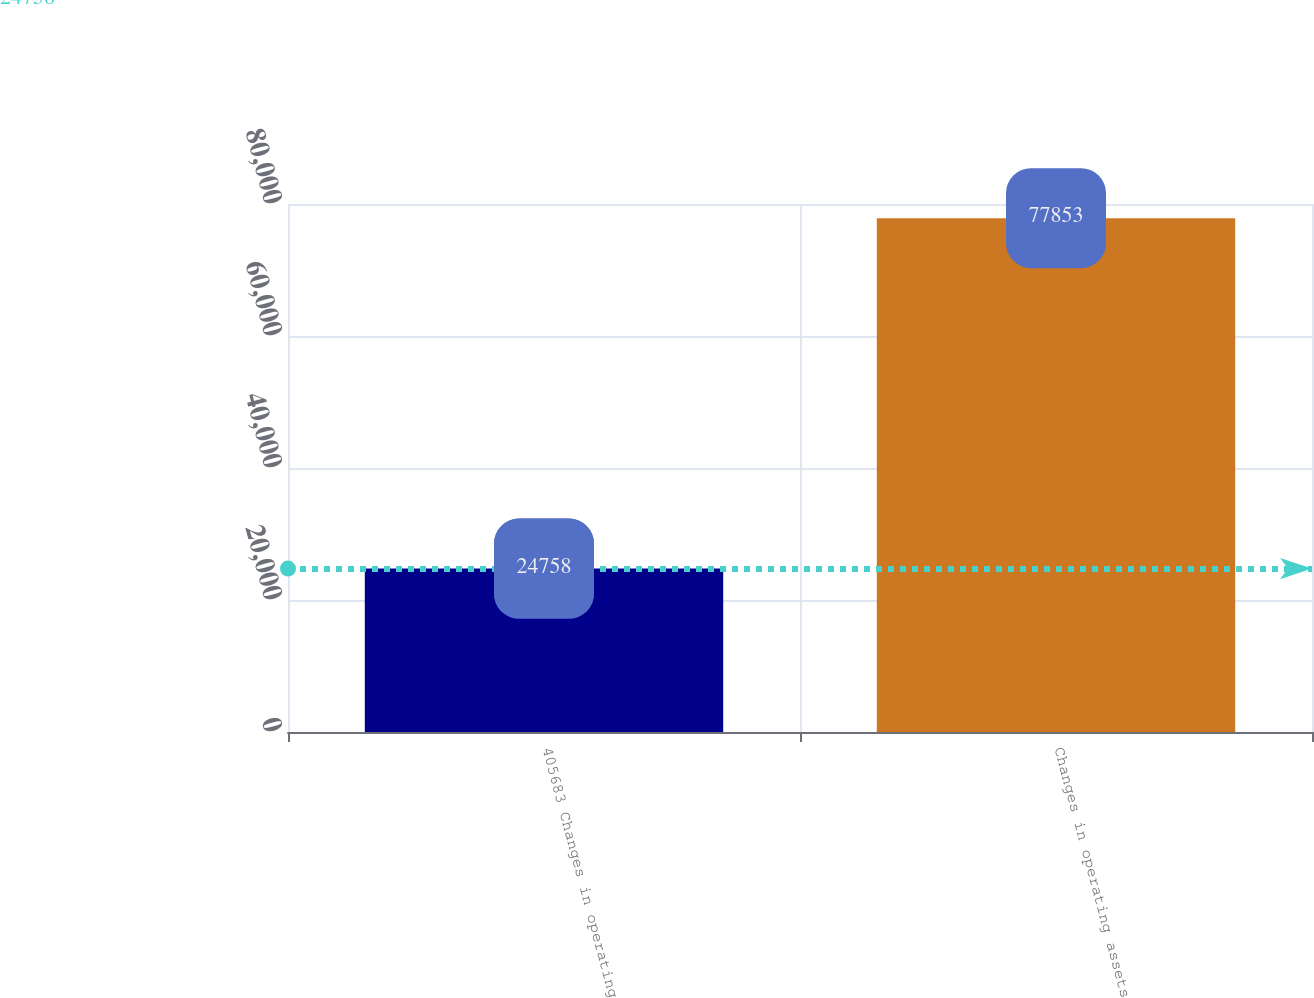<chart> <loc_0><loc_0><loc_500><loc_500><bar_chart><fcel>405683 Changes in operating<fcel>Changes in operating assets<nl><fcel>24758<fcel>77853<nl></chart> 